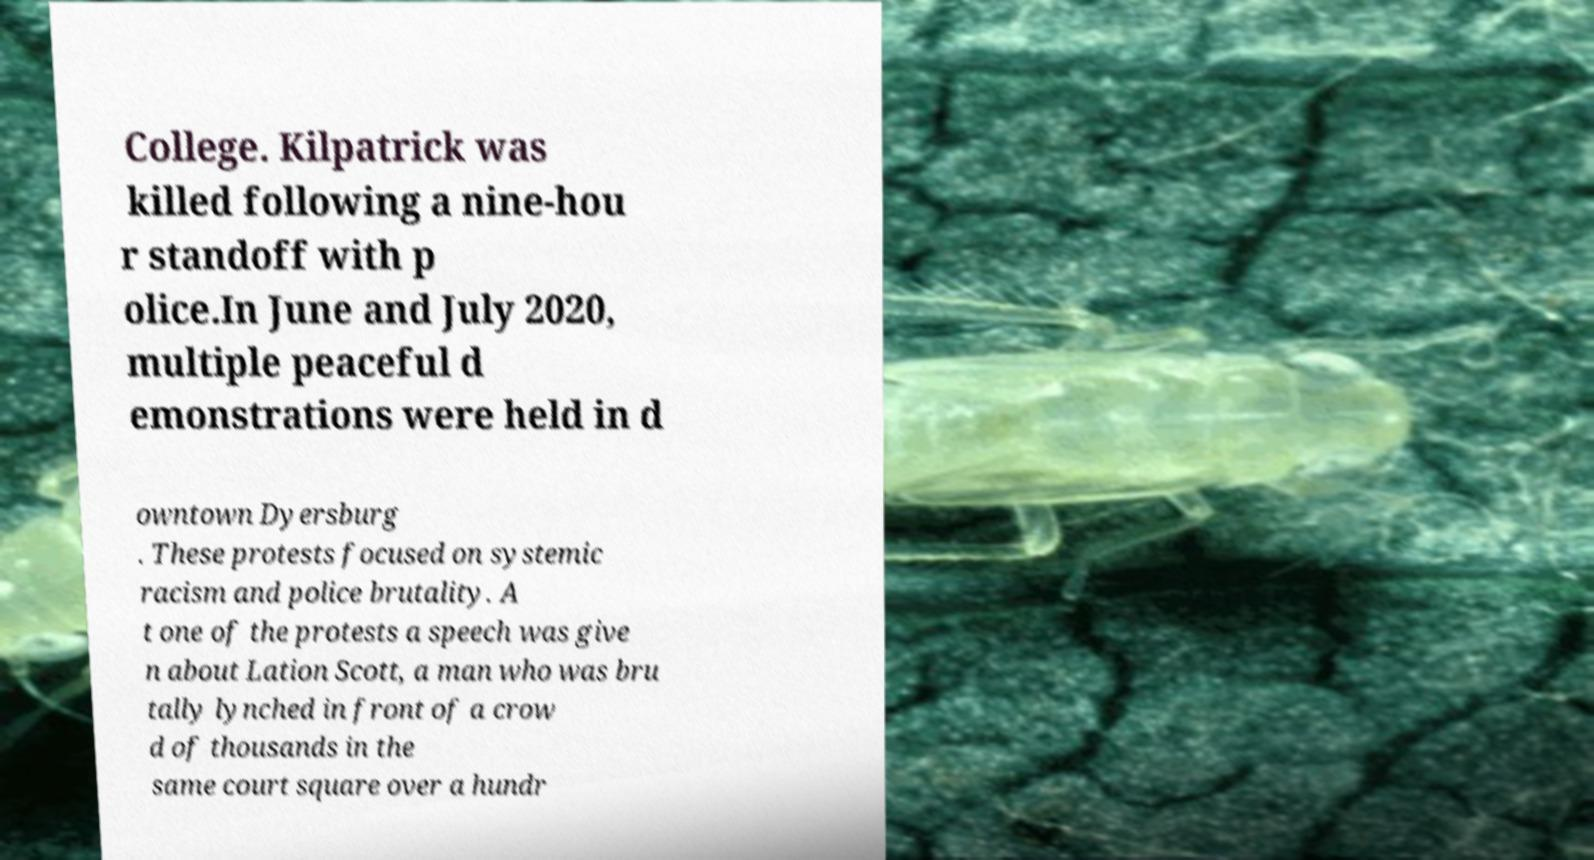Can you accurately transcribe the text from the provided image for me? College. Kilpatrick was killed following a nine-hou r standoff with p olice.In June and July 2020, multiple peaceful d emonstrations were held in d owntown Dyersburg . These protests focused on systemic racism and police brutality. A t one of the protests a speech was give n about Lation Scott, a man who was bru tally lynched in front of a crow d of thousands in the same court square over a hundr 